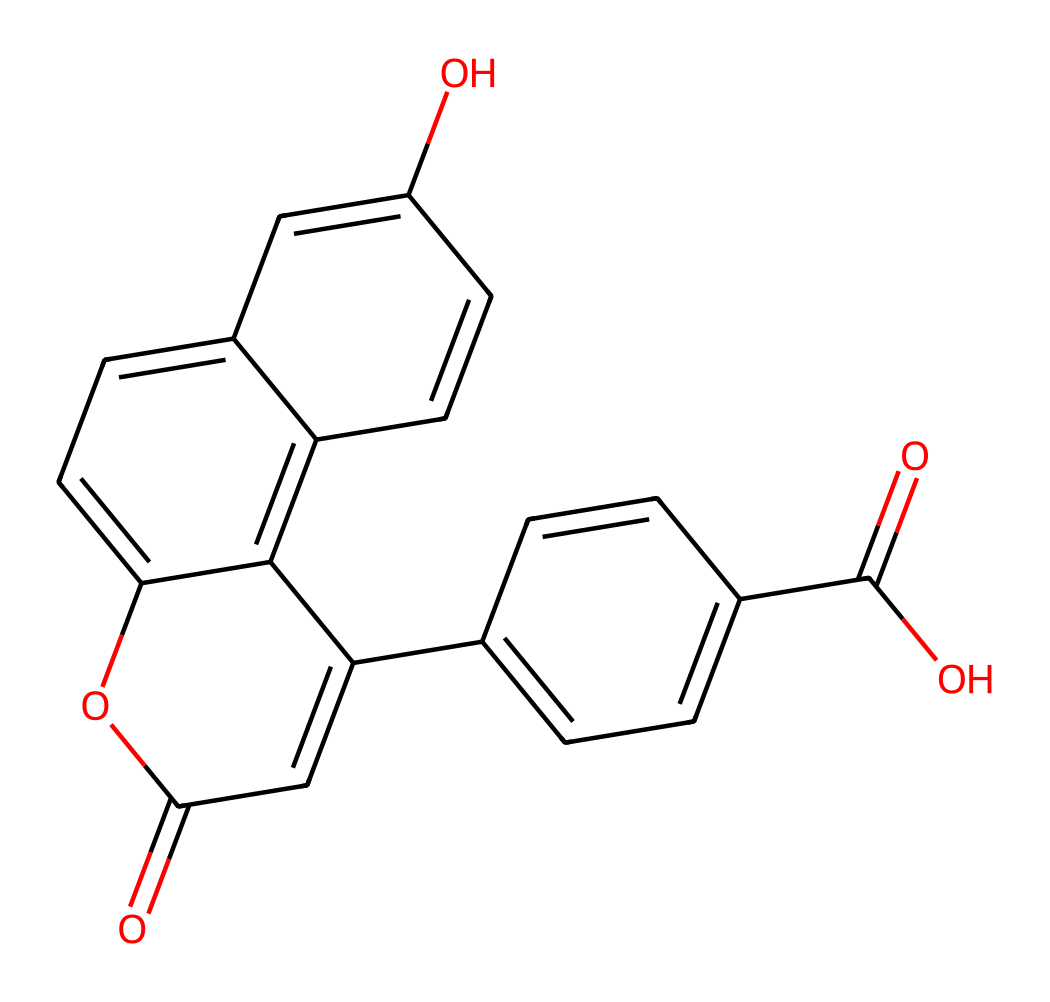What is the molecular formula of fluorescein? The structure can be analyzed to count the number of carbon (C), hydrogen (H), and oxygen (O) atoms. In this case, there are 22 carbons (C), 20 hydrogens (H), and 2 oxygens (O), leading to the molecular formula C22H20O2.
Answer: C22H20O2 How many rings are present in this structure? By examining the chemical structure, one can identify the cyclic portions embedded in the molecule. There are three distinct rings in the fluorescein structure formed from interconnected carbon atoms.
Answer: 3 What type of compounds does fluorescein belong to? Upon reviewing the functional groups in the chemical structure, fluorescein contains a conjugated system that is characteristic of dyes, specifically, it is a fluorescent dye due to its properties.
Answer: fluorescent dye What type of functional groups are found in fluorescein? Analyzing the structure shows that fluorescein contains carboxylic acid (due to -COOH) and alcohol (-OH) functional groups. This diverse arrangement contributes to its solubility and reactivity.
Answer: carboxylic acid, alcohol What is the effect of the double bonds present in fluorescein on its properties? The double bonds in fluorescein contribute to its conjugated system, which is vital for the absorption of light, allowing it to fluoresce. This feature is crucial for its application in diagnostics.
Answer: fluorescence 